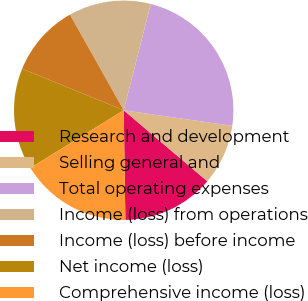Convert chart to OTSL. <chart><loc_0><loc_0><loc_500><loc_500><pie_chart><fcel>Research and development<fcel>Selling general and<fcel>Total operating expenses<fcel>Income (loss) from operations<fcel>Income (loss) before income<fcel>Net income (loss)<fcel>Comprehensive income (loss)<nl><fcel>13.55%<fcel>8.94%<fcel>23.3%<fcel>12.12%<fcel>10.68%<fcel>14.99%<fcel>16.43%<nl></chart> 